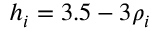Convert formula to latex. <formula><loc_0><loc_0><loc_500><loc_500>h _ { i } = 3 . 5 - 3 \rho _ { i }</formula> 